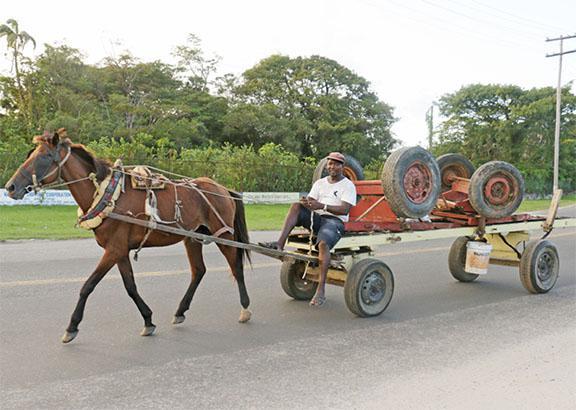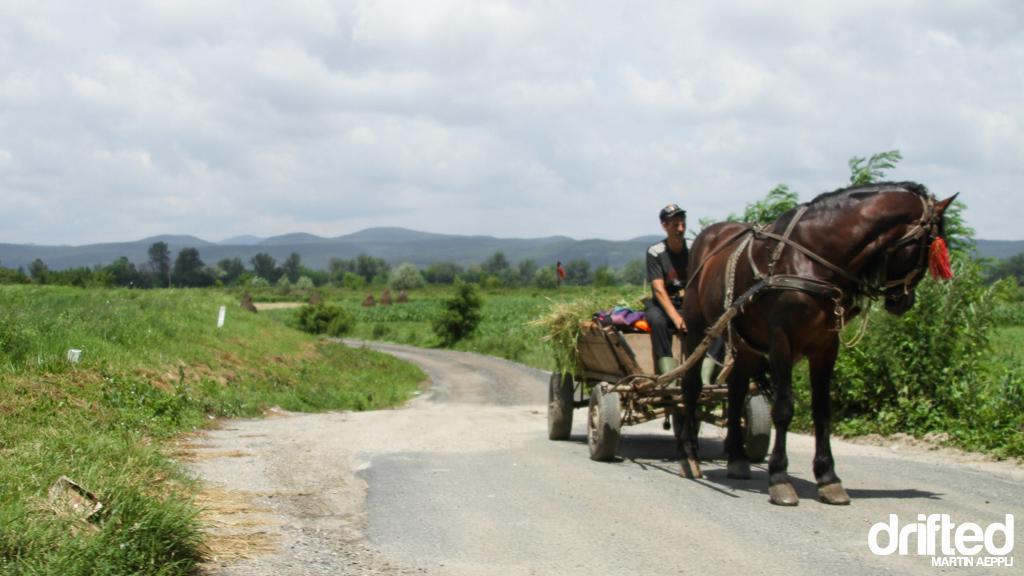The first image is the image on the left, the second image is the image on the right. Examine the images to the left and right. Is the description "The carriages are being pulled by brown horses." accurate? Answer yes or no. Yes. The first image is the image on the left, the second image is the image on the right. Given the left and right images, does the statement "At least one wagon is carrying more than one person." hold true? Answer yes or no. No. 